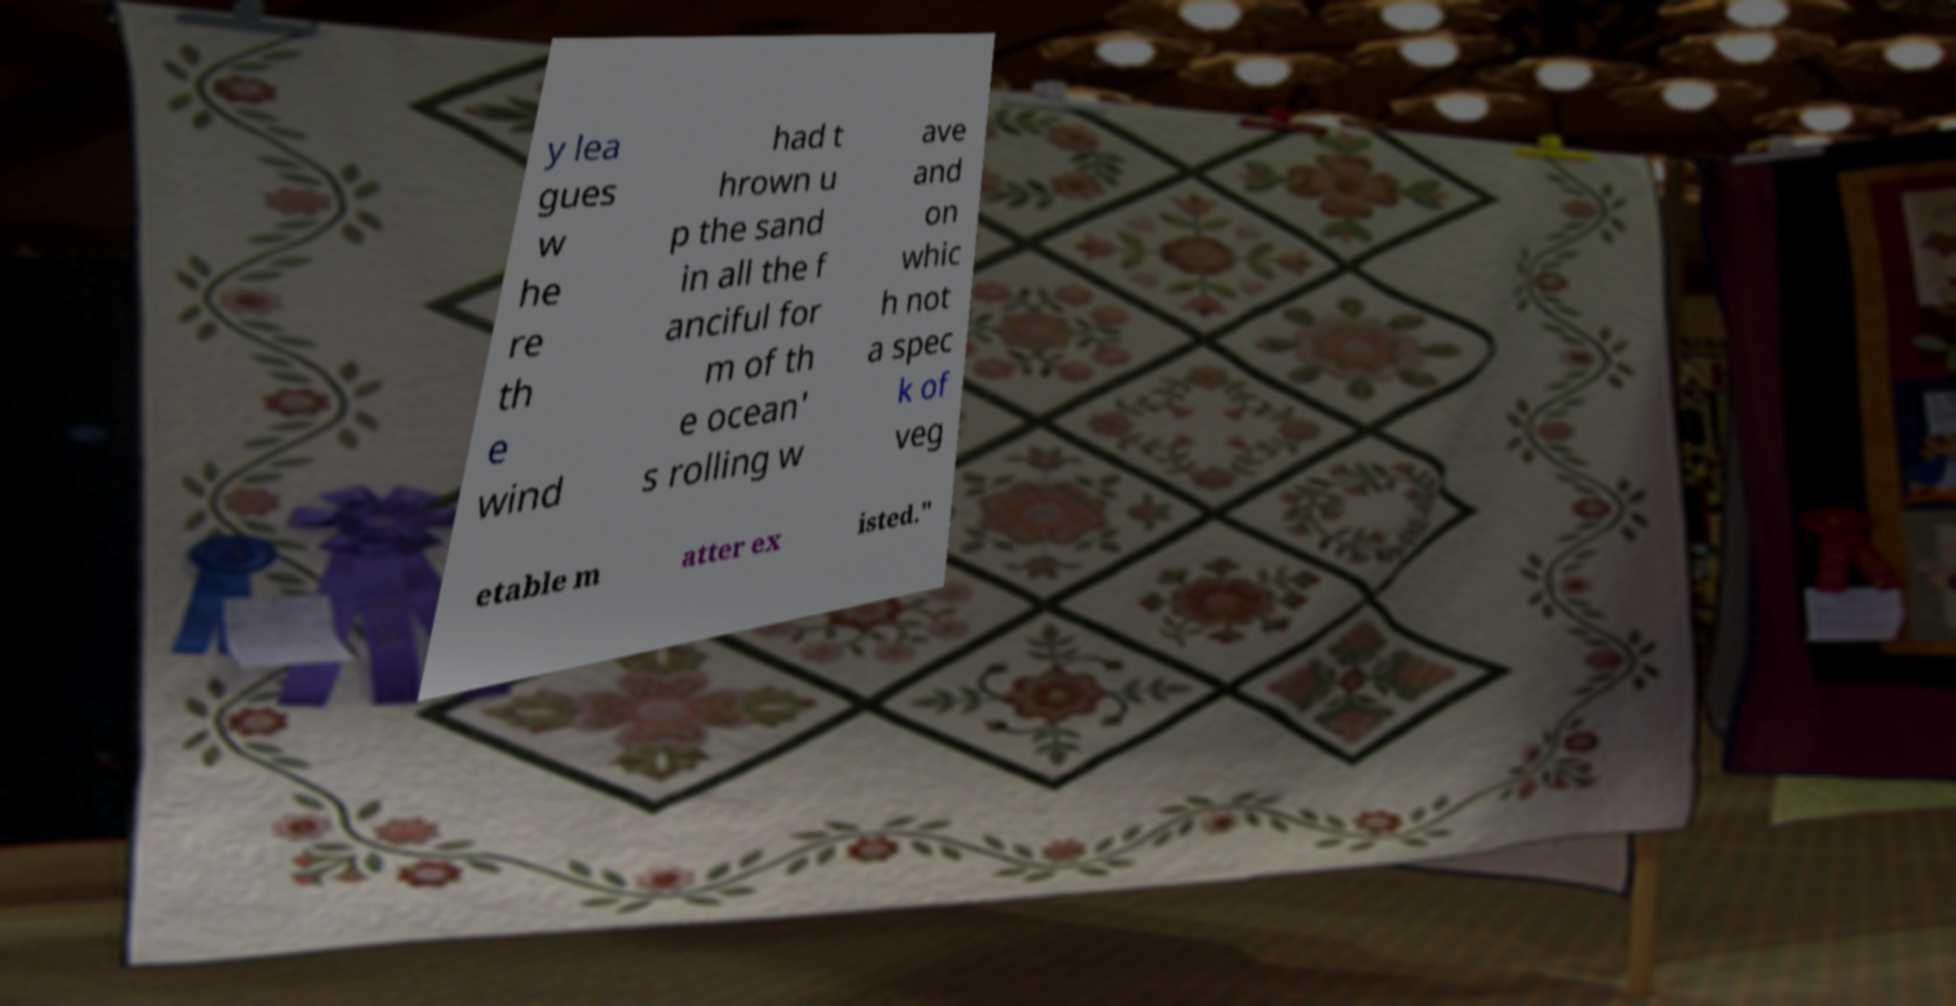There's text embedded in this image that I need extracted. Can you transcribe it verbatim? y lea gues w he re th e wind had t hrown u p the sand in all the f anciful for m of th e ocean' s rolling w ave and on whic h not a spec k of veg etable m atter ex isted." 